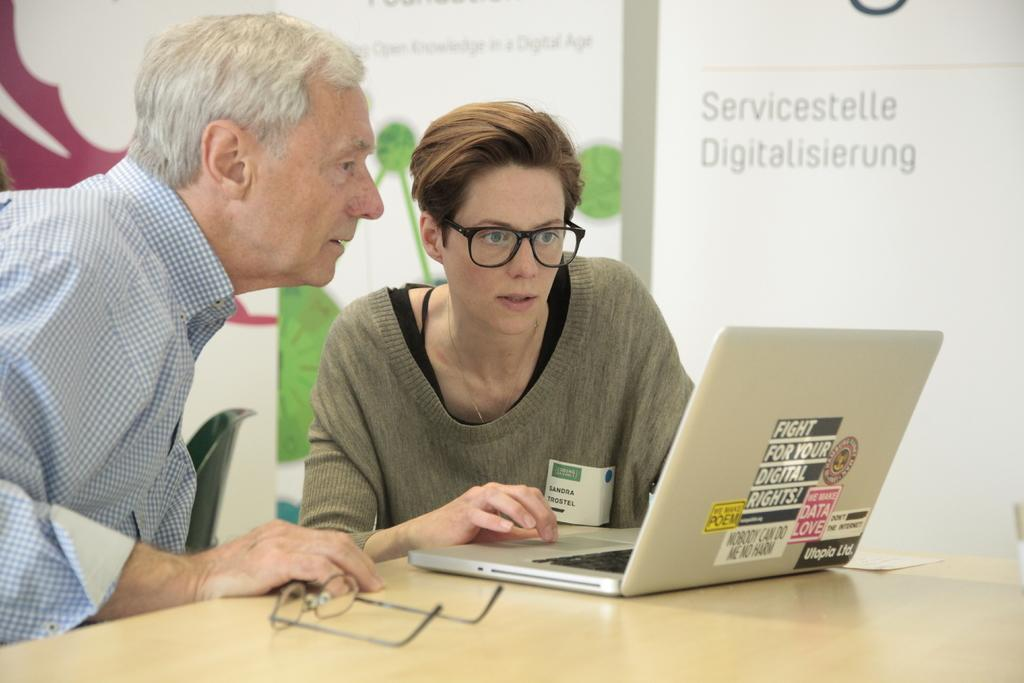How many people are in the image? There are two men in the image. What are the men doing in the image? The men are sitting beside a table. What objects can be seen on the table? The table contains a laptop, paper, and glasses. What can be seen in the background of the image? There is a chair and a wall with text on it in the background. Can you hear the noise of the stream in the image? There is no stream or noise present in the image. What type of rock is visible on the table? There is no rock visible on the table; it contains a laptop, paper, and glasses. 